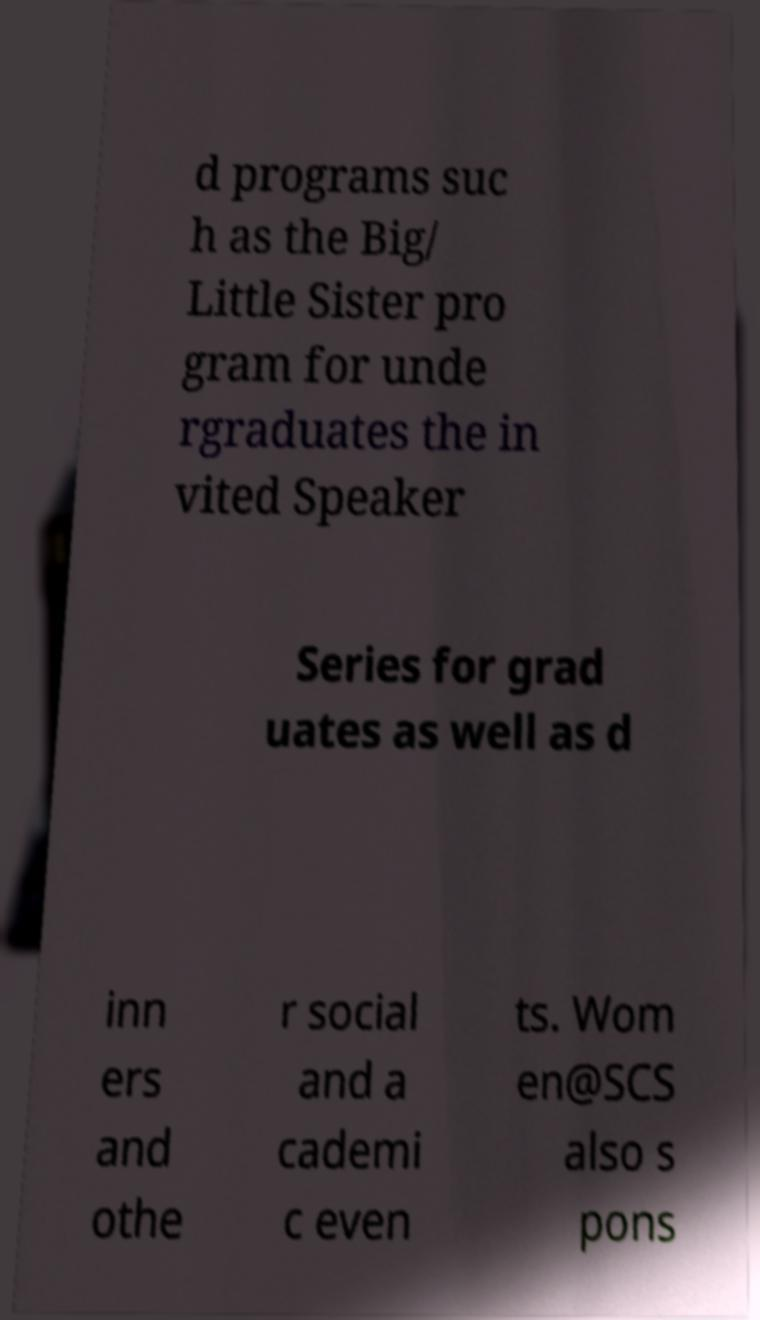Can you read and provide the text displayed in the image?This photo seems to have some interesting text. Can you extract and type it out for me? d programs suc h as the Big/ Little Sister pro gram for unde rgraduates the in vited Speaker Series for grad uates as well as d inn ers and othe r social and a cademi c even ts. Wom en@SCS also s pons 